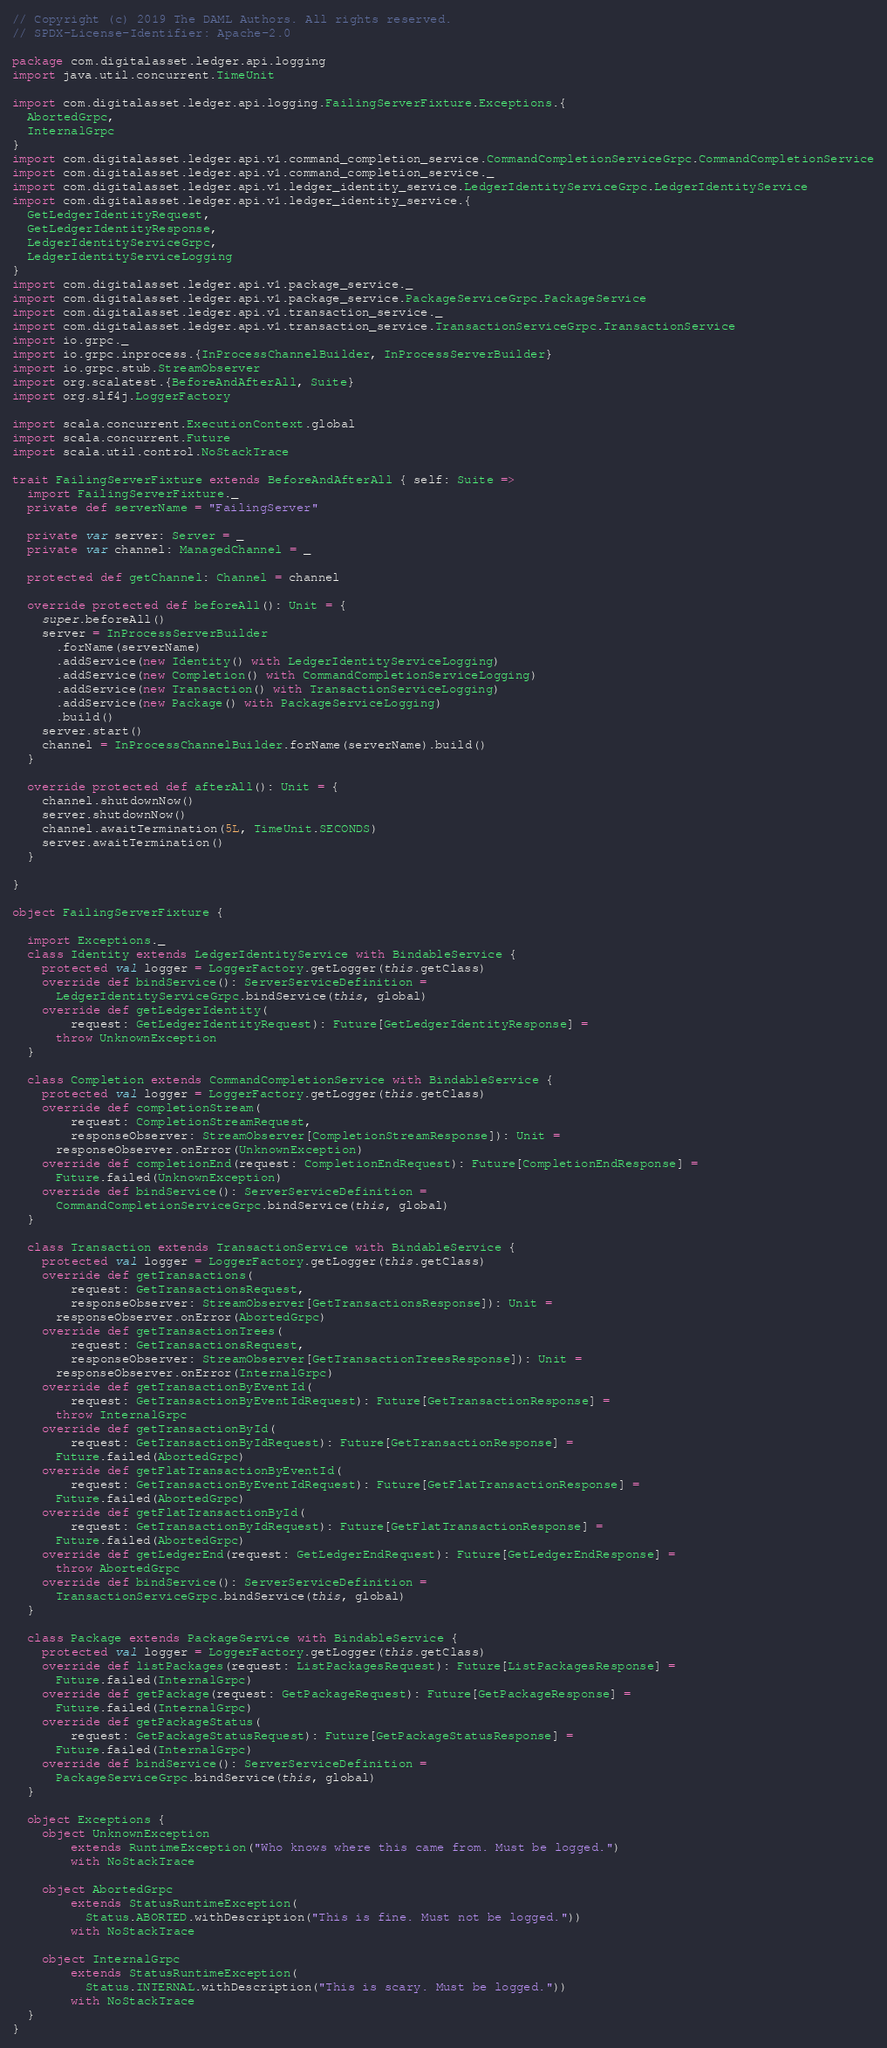Convert code to text. <code><loc_0><loc_0><loc_500><loc_500><_Scala_>// Copyright (c) 2019 The DAML Authors. All rights reserved.
// SPDX-License-Identifier: Apache-2.0

package com.digitalasset.ledger.api.logging
import java.util.concurrent.TimeUnit

import com.digitalasset.ledger.api.logging.FailingServerFixture.Exceptions.{
  AbortedGrpc,
  InternalGrpc
}
import com.digitalasset.ledger.api.v1.command_completion_service.CommandCompletionServiceGrpc.CommandCompletionService
import com.digitalasset.ledger.api.v1.command_completion_service._
import com.digitalasset.ledger.api.v1.ledger_identity_service.LedgerIdentityServiceGrpc.LedgerIdentityService
import com.digitalasset.ledger.api.v1.ledger_identity_service.{
  GetLedgerIdentityRequest,
  GetLedgerIdentityResponse,
  LedgerIdentityServiceGrpc,
  LedgerIdentityServiceLogging
}
import com.digitalasset.ledger.api.v1.package_service._
import com.digitalasset.ledger.api.v1.package_service.PackageServiceGrpc.PackageService
import com.digitalasset.ledger.api.v1.transaction_service._
import com.digitalasset.ledger.api.v1.transaction_service.TransactionServiceGrpc.TransactionService
import io.grpc._
import io.grpc.inprocess.{InProcessChannelBuilder, InProcessServerBuilder}
import io.grpc.stub.StreamObserver
import org.scalatest.{BeforeAndAfterAll, Suite}
import org.slf4j.LoggerFactory

import scala.concurrent.ExecutionContext.global
import scala.concurrent.Future
import scala.util.control.NoStackTrace

trait FailingServerFixture extends BeforeAndAfterAll { self: Suite =>
  import FailingServerFixture._
  private def serverName = "FailingServer"

  private var server: Server = _
  private var channel: ManagedChannel = _

  protected def getChannel: Channel = channel

  override protected def beforeAll(): Unit = {
    super.beforeAll()
    server = InProcessServerBuilder
      .forName(serverName)
      .addService(new Identity() with LedgerIdentityServiceLogging)
      .addService(new Completion() with CommandCompletionServiceLogging)
      .addService(new Transaction() with TransactionServiceLogging)
      .addService(new Package() with PackageServiceLogging)
      .build()
    server.start()
    channel = InProcessChannelBuilder.forName(serverName).build()
  }

  override protected def afterAll(): Unit = {
    channel.shutdownNow()
    server.shutdownNow()
    channel.awaitTermination(5L, TimeUnit.SECONDS)
    server.awaitTermination()
  }

}

object FailingServerFixture {

  import Exceptions._
  class Identity extends LedgerIdentityService with BindableService {
    protected val logger = LoggerFactory.getLogger(this.getClass)
    override def bindService(): ServerServiceDefinition =
      LedgerIdentityServiceGrpc.bindService(this, global)
    override def getLedgerIdentity(
        request: GetLedgerIdentityRequest): Future[GetLedgerIdentityResponse] =
      throw UnknownException
  }

  class Completion extends CommandCompletionService with BindableService {
    protected val logger = LoggerFactory.getLogger(this.getClass)
    override def completionStream(
        request: CompletionStreamRequest,
        responseObserver: StreamObserver[CompletionStreamResponse]): Unit =
      responseObserver.onError(UnknownException)
    override def completionEnd(request: CompletionEndRequest): Future[CompletionEndResponse] =
      Future.failed(UnknownException)
    override def bindService(): ServerServiceDefinition =
      CommandCompletionServiceGrpc.bindService(this, global)
  }

  class Transaction extends TransactionService with BindableService {
    protected val logger = LoggerFactory.getLogger(this.getClass)
    override def getTransactions(
        request: GetTransactionsRequest,
        responseObserver: StreamObserver[GetTransactionsResponse]): Unit =
      responseObserver.onError(AbortedGrpc)
    override def getTransactionTrees(
        request: GetTransactionsRequest,
        responseObserver: StreamObserver[GetTransactionTreesResponse]): Unit =
      responseObserver.onError(InternalGrpc)
    override def getTransactionByEventId(
        request: GetTransactionByEventIdRequest): Future[GetTransactionResponse] =
      throw InternalGrpc
    override def getTransactionById(
        request: GetTransactionByIdRequest): Future[GetTransactionResponse] =
      Future.failed(AbortedGrpc)
    override def getFlatTransactionByEventId(
        request: GetTransactionByEventIdRequest): Future[GetFlatTransactionResponse] =
      Future.failed(AbortedGrpc)
    override def getFlatTransactionById(
        request: GetTransactionByIdRequest): Future[GetFlatTransactionResponse] =
      Future.failed(AbortedGrpc)
    override def getLedgerEnd(request: GetLedgerEndRequest): Future[GetLedgerEndResponse] =
      throw AbortedGrpc
    override def bindService(): ServerServiceDefinition =
      TransactionServiceGrpc.bindService(this, global)
  }

  class Package extends PackageService with BindableService {
    protected val logger = LoggerFactory.getLogger(this.getClass)
    override def listPackages(request: ListPackagesRequest): Future[ListPackagesResponse] =
      Future.failed(InternalGrpc)
    override def getPackage(request: GetPackageRequest): Future[GetPackageResponse] =
      Future.failed(InternalGrpc)
    override def getPackageStatus(
        request: GetPackageStatusRequest): Future[GetPackageStatusResponse] =
      Future.failed(InternalGrpc)
    override def bindService(): ServerServiceDefinition =
      PackageServiceGrpc.bindService(this, global)
  }

  object Exceptions {
    object UnknownException
        extends RuntimeException("Who knows where this came from. Must be logged.")
        with NoStackTrace

    object AbortedGrpc
        extends StatusRuntimeException(
          Status.ABORTED.withDescription("This is fine. Must not be logged."))
        with NoStackTrace

    object InternalGrpc
        extends StatusRuntimeException(
          Status.INTERNAL.withDescription("This is scary. Must be logged."))
        with NoStackTrace
  }
}
</code> 